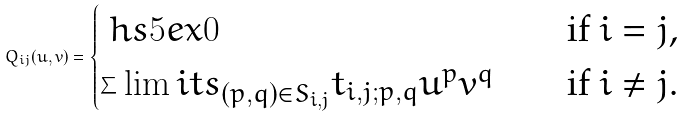Convert formula to latex. <formula><loc_0><loc_0><loc_500><loc_500>Q _ { i j } ( u , v ) = \begin{cases} \ h s { 5 e x } 0 \ \ & \text {if $i=j$,} \\ \sum \lim i t s _ { ( p , q ) \in S _ { i , j } } t _ { i , j ; p , q } u ^ { p } v ^ { q } \quad & \text {if $i \neq j$.} \end{cases}</formula> 